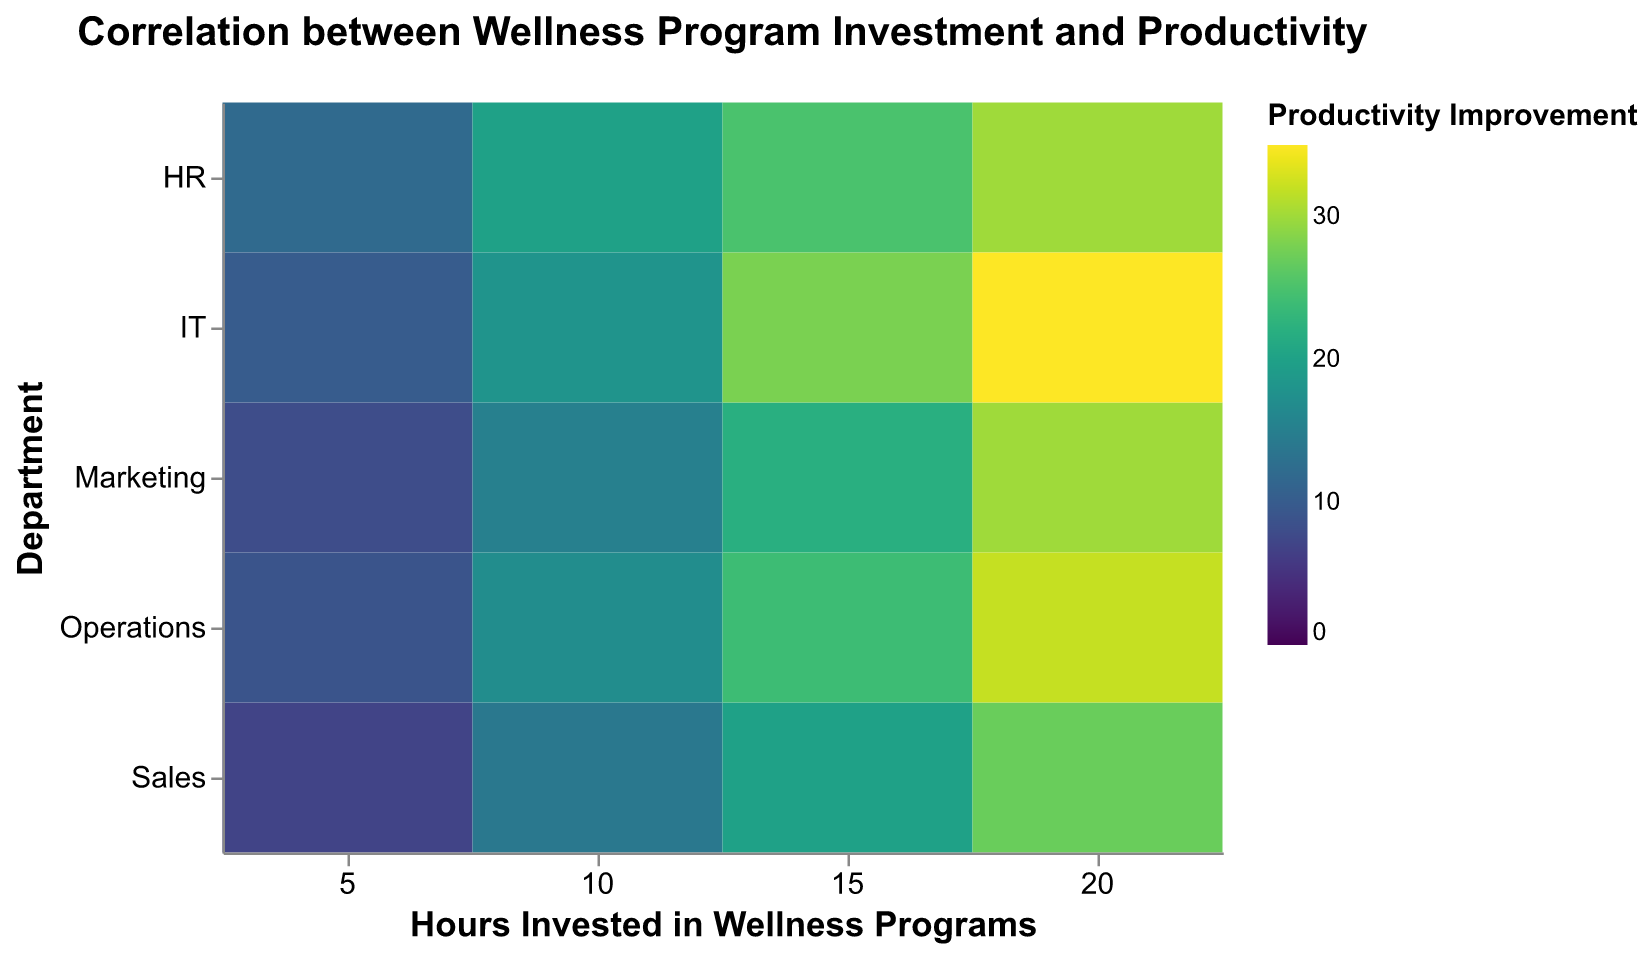What is the title of the figure? The title is displayed at the top center of the figure.
Answer: "Correlation between Wellness Program Investment and Productivity" Which department has the highest productivity improvement with 20 hours invested in wellness programs? Look at the column where 'Hours Invested in Wellness Programs' is 20 and find the row with the highest value under 'Productivity Improvement'.
Answer: IT What is the productivity improvement for the Marketing department with 10 hours invested in wellness programs? Locate the column for 'Hours Invested in Wellness Programs' at 10, and then find the intersection with the row for the Marketing department.
Answer: 15 Among HR, Sales, and IT, which department shows the highest productivity improvement for 15 hours invested in wellness programs? Identify the values for each department at 15 hours and compare them.
Answer: IT What is the average productivity improvement in the Operations department across all levels of hours invested in wellness programs? Add the productivity improvements for Operations (9, 17, 24, 32) and divide by the number of data points (4). The sum is 82, and the average is 82/4.
Answer: 20.5 Compare the productivity improvement of the Sales and Marketing departments with 20 hours invested in wellness programs. Which one is higher, and by how much? Identify and compare the values for 'Sales' and 'Marketing' at 20 hours, then calculate the difference (27 for Sales, 30 for Marketing; 30 - 27 = 3).
Answer: Marketing by 3 How does the productivity improvement change as the hours invested in wellness programs increase for HR? Observe the trend in the 'HR' row. The values are increasing from 12 to 20 to 25 to 30 as hours increase.
Answer: Increases Which department shows the least productivity improvement with 5 hours invested in wellness programs? Identify the values for each department for 5 hours invested and find the minimum value.
Answer: Sales Does the IT department have a consistent increase in productivity improvement with an increase in hours invested? Look at the trend in the 'IT' row. The values progressively increase (10, 18, 28, 35).
Answer: Yes What is the total productivity improvement of all departments with 20 hours invested in wellness programs? Sum the productivity improvements at 20 hours for all departments (30 + 30 + 35 + 27 + 32). The total is 154.
Answer: 154 